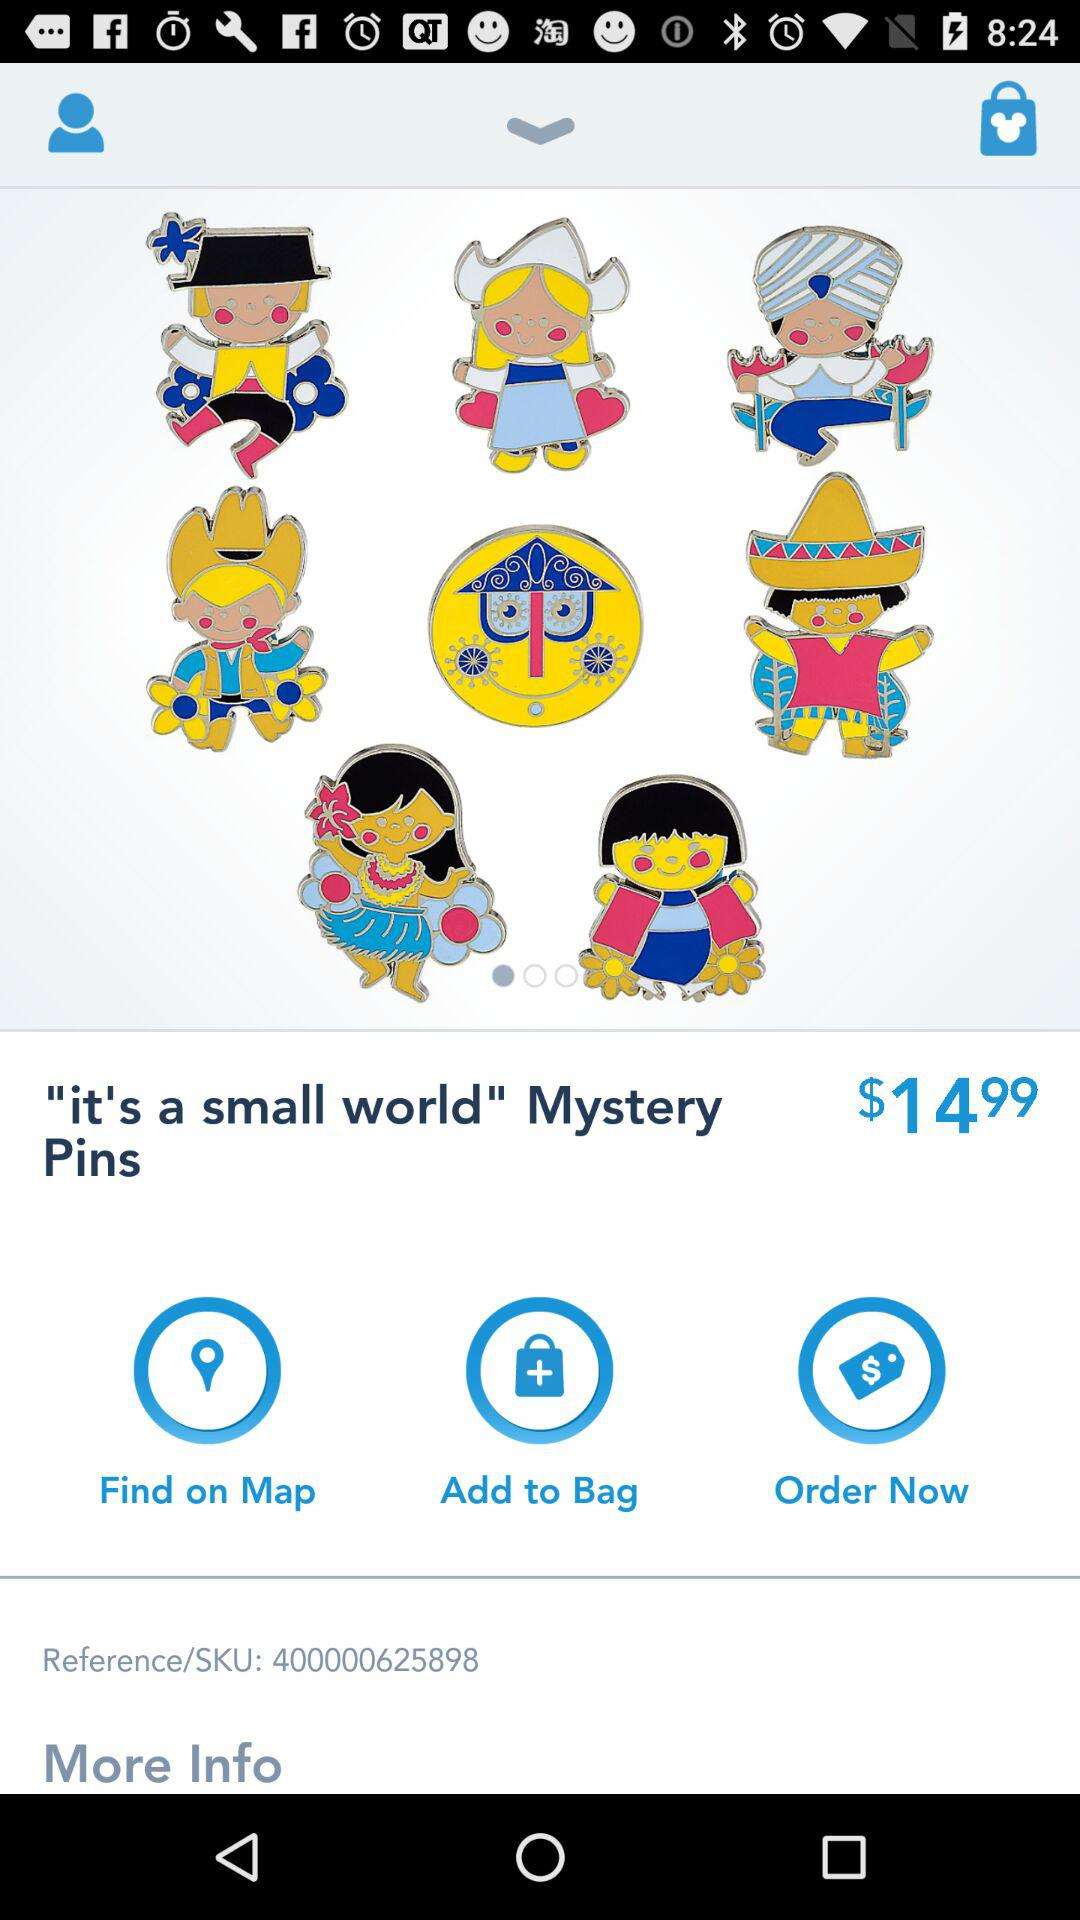What is the reference number? The reference number is 400000625898. 